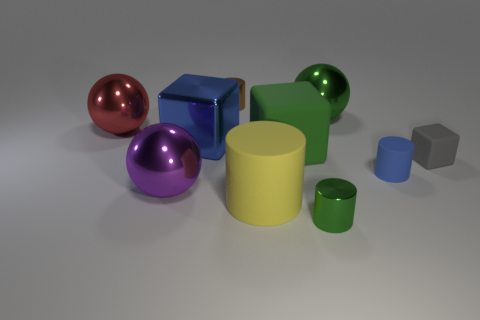Subtract all large green spheres. How many spheres are left? 2 Subtract all blue cylinders. How many cylinders are left? 3 Subtract 2 spheres. How many spheres are left? 1 Subtract all tiny green cubes. Subtract all shiny spheres. How many objects are left? 7 Add 9 tiny brown objects. How many tiny brown objects are left? 10 Add 6 tiny rubber cubes. How many tiny rubber cubes exist? 7 Subtract 0 red cubes. How many objects are left? 10 Subtract all spheres. How many objects are left? 7 Subtract all yellow cylinders. Subtract all cyan blocks. How many cylinders are left? 3 